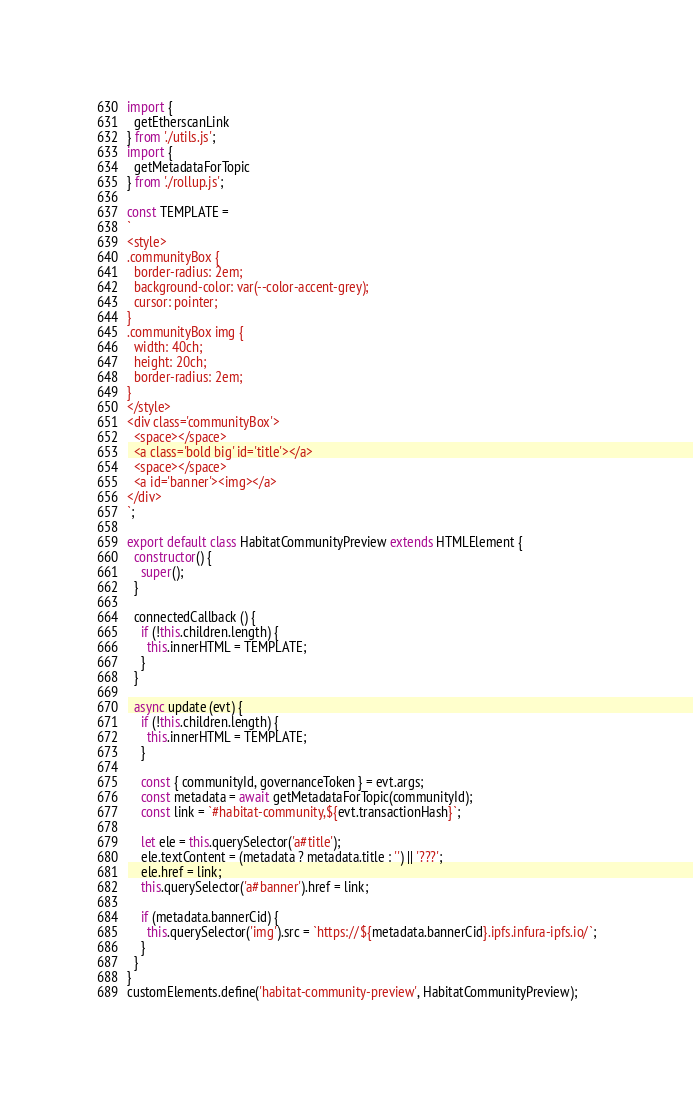Convert code to text. <code><loc_0><loc_0><loc_500><loc_500><_JavaScript_>import {
  getEtherscanLink
} from './utils.js';
import {
  getMetadataForTopic
} from './rollup.js';

const TEMPLATE =
`
<style>
.communityBox {
  border-radius: 2em;
  background-color: var(--color-accent-grey);
  cursor: pointer;
}
.communityBox img {
  width: 40ch;
  height: 20ch;
  border-radius: 2em;
}
</style>
<div class='communityBox'>
  <space></space>
  <a class='bold big' id='title'></a>
  <space></space>
  <a id='banner'><img></a>
</div>
`;

export default class HabitatCommunityPreview extends HTMLElement {
  constructor() {
    super();
  }

  connectedCallback () {
    if (!this.children.length) {
      this.innerHTML = TEMPLATE;
    }
  }

  async update (evt) {
    if (!this.children.length) {
      this.innerHTML = TEMPLATE;
    }

    const { communityId, governanceToken } = evt.args;
    const metadata = await getMetadataForTopic(communityId);
    const link = `#habitat-community,${evt.transactionHash}`;

    let ele = this.querySelector('a#title');
    ele.textContent = (metadata ? metadata.title : '') || '???';
    ele.href = link;
    this.querySelector('a#banner').href = link;

    if (metadata.bannerCid) {
      this.querySelector('img').src = `https://${metadata.bannerCid}.ipfs.infura-ipfs.io/`;
    }
  }
}
customElements.define('habitat-community-preview', HabitatCommunityPreview);
</code> 